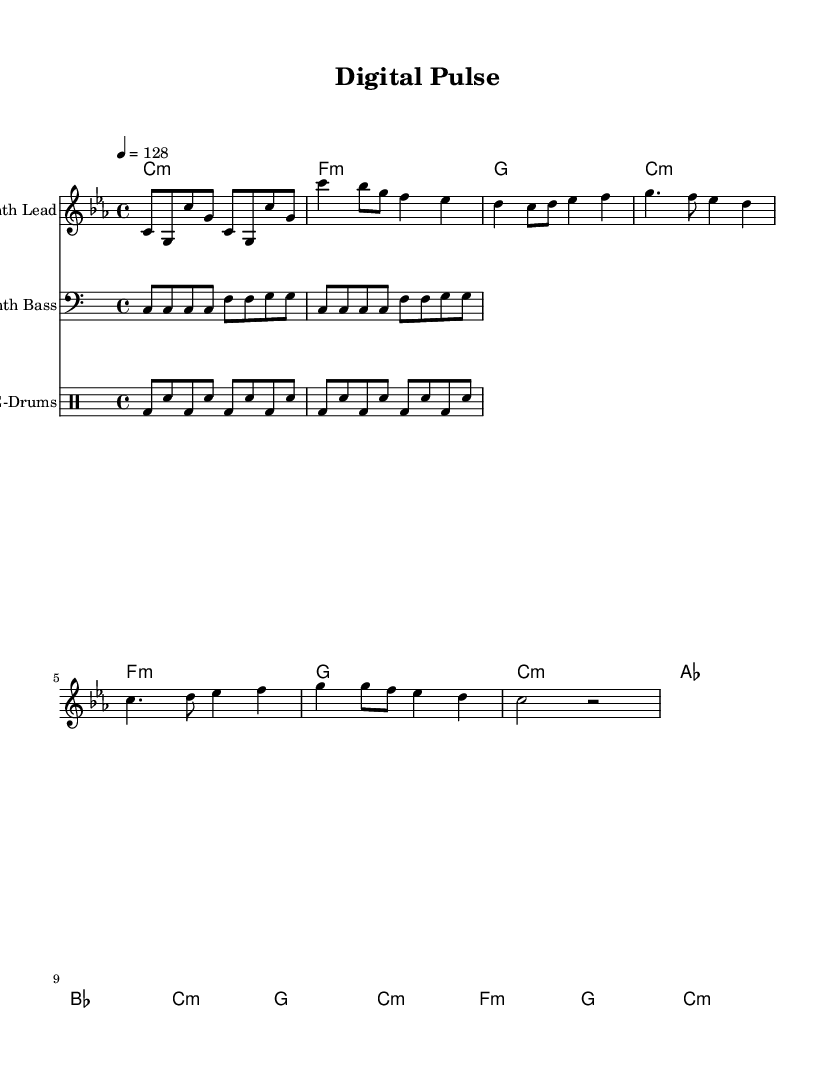What is the key signature of this music? The key signature, indicated at the beginning of the music, shows three flats, which correspond to the key of C minor.
Answer: C minor What is the time signature of this piece? The time signature at the beginning is shown as 4/4, which indicates that there are four beats in each measure and the quarter note gets one beat.
Answer: 4/4 What is the tempo marking indicated on the sheet music? The tempo marking shows a value of 128, indicating the speed of the piece, which is performed at 128 beats per minute.
Answer: 128 How many measures are in the chorus section? By examining the chorus, which includes specific note patterns, it can be counted that there are four measures in this section: each line corresponds to a measure.
Answer: 4 What instrument is indicated as playing the melody? The sheet specifies a staff labeled "Synth Lead," indicating that the melody is being played by this instrument.
Answer: Synth Lead What is the function of the synth bass in this arrangement? The bass is indicated to provide a harmonic foundation and rhythmic support, typically enhancing the overall texture and depth of the music.
Answer: Harmonic foundation Which musical section follows the verse in this piece? The music structure reveals that the pre-chorus follows the verse as a transitional section before reaching the chorus.
Answer: Pre-Chorus 